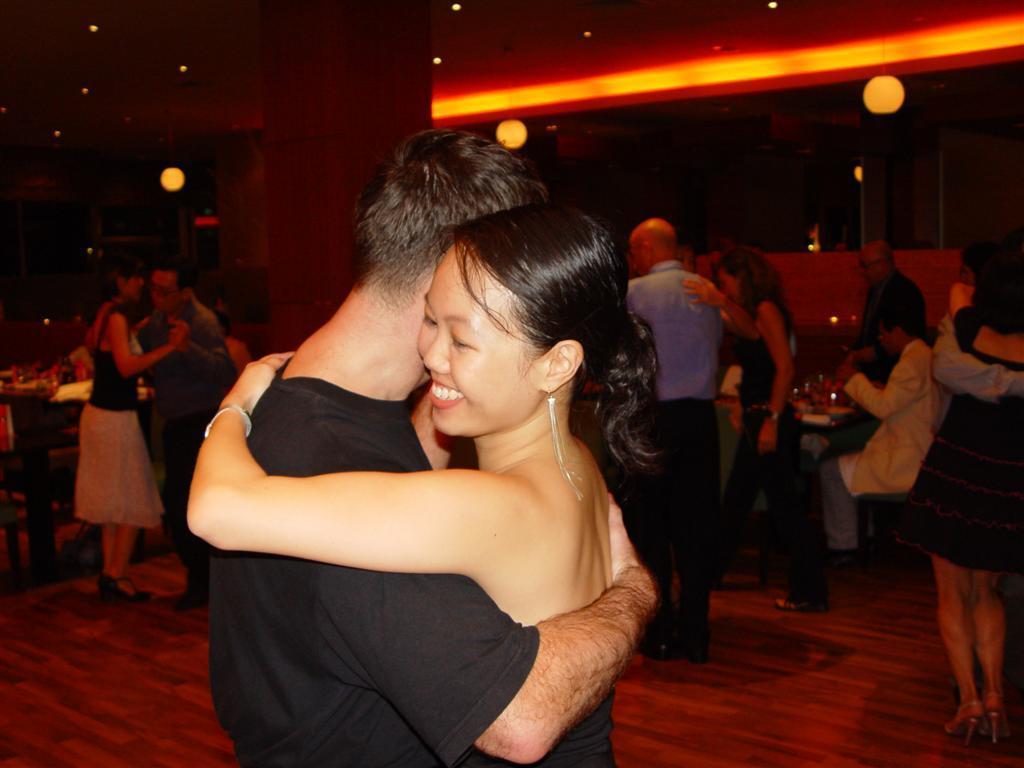How would you summarize this image in a sentence or two? This is an image clicked in the dark. In the foreground, I can see a man and a woman wearing black color dresses, holding each other. The woman is smiling. In the background, I can see some more people, few are sitting on the chairs and few are dancing on the floor. On the left side, I can see table. On the table, I can see few objects. In the background there is a wall. At the top I can see few lights. 